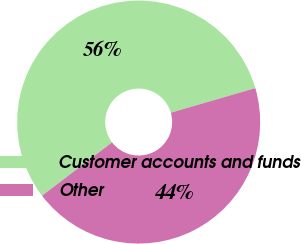<chart> <loc_0><loc_0><loc_500><loc_500><pie_chart><fcel>Customer accounts and funds<fcel>Other<nl><fcel>55.86%<fcel>44.14%<nl></chart> 